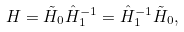<formula> <loc_0><loc_0><loc_500><loc_500>H = \tilde { H } _ { 0 } \hat { H } _ { 1 } ^ { - 1 } = \hat { H } _ { 1 } ^ { - 1 } \tilde { H } _ { 0 } ,</formula> 